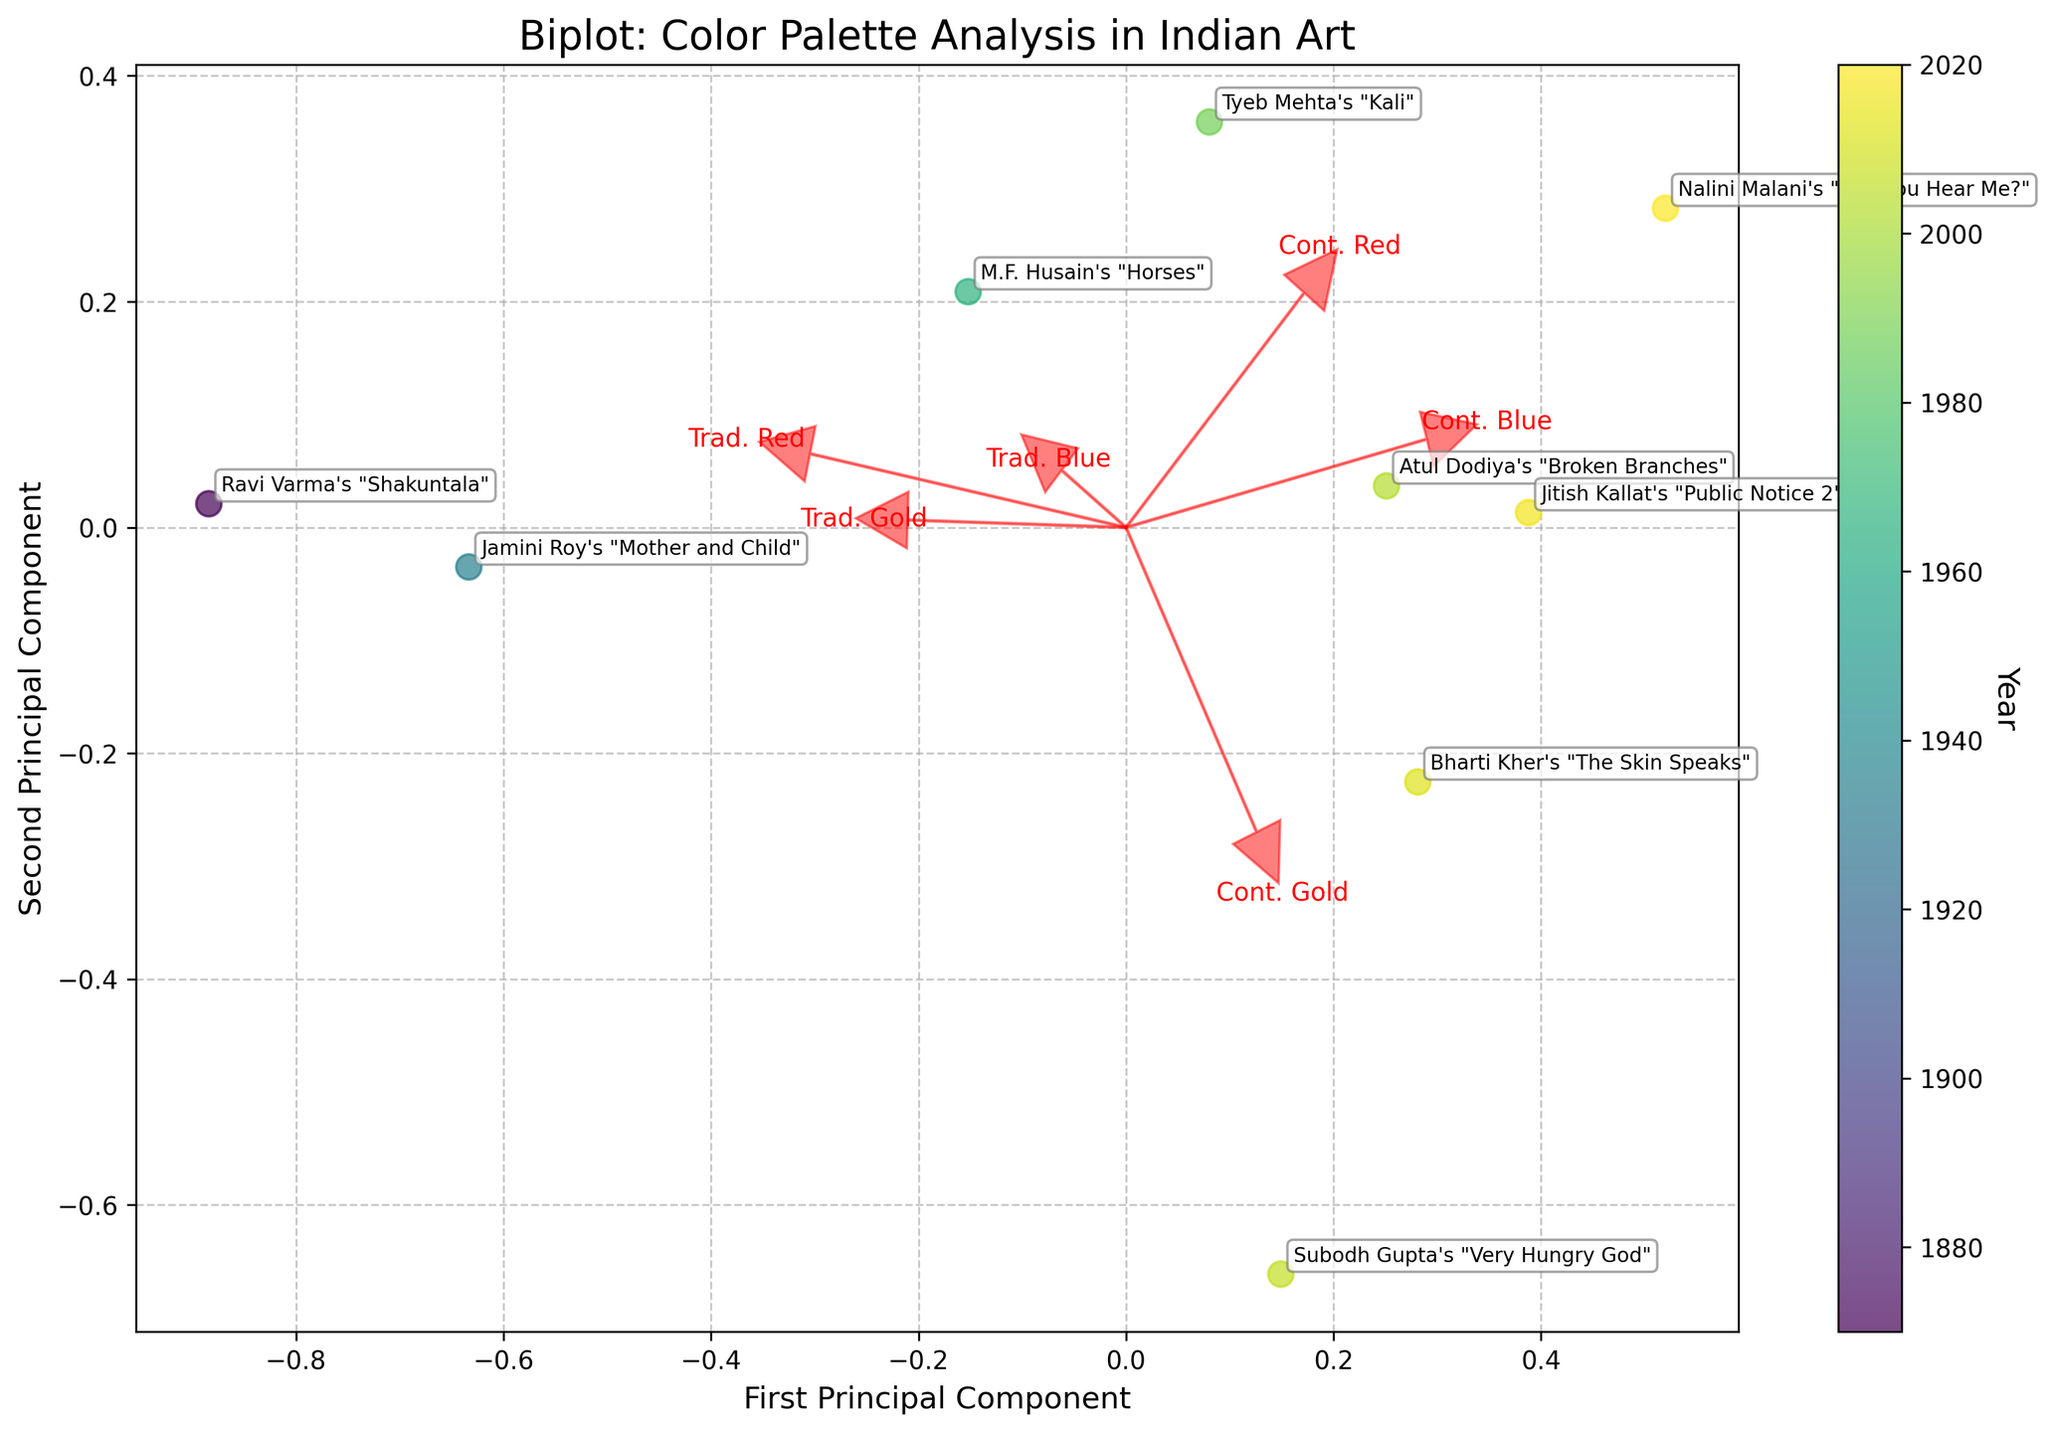What's the title of the plot? The title is found at the top of the figure where it summarizes the main subject or purpose of the plot. Here it is titled "Biplot: Color Palette Analysis in Indian Art".
Answer: Biplot: Color Palette Analysis in Indian Art What are the labels of the axes in the plot? The labels of the axes can be found on the horizontal (x-axis) and vertical (y-axis). For this plot, the horizontal axis is labeled "First Principal Component" and the vertical axis is labeled "Second Principal Component".
Answer: First Principal Component, Second Principal Component How are the years represented in the plot? The years of the artworks are indicated by the color of the data points in the scatter plot. The color gradient ranges from a certain start year to end year, represented by the color bar on the right side of the plot.
Answer: By the color of the data points Which artwork is projected closest to the First Principal Component axis? The artwork closest to the First Principal Component axis is the one with the smallest value on the Second Principal Component axis. In this figure, it's "Jitish Kallat's 'Public Notice 2'".
Answer: Jitish Kallat's "Public Notice 2" Among the artworks, which one used the highest proportion of Contemporary Gold? This can be identified by looking at the vector labeled "Cont. Gold" and checking the closest projection to that vector among the data points. "Subodh Gupta's 'Very Hungry God'" is closest to this vector.
Answer: Subodh Gupta's "Very Hungry God" What trend in the color palette usage can be inferred from the arrows for traditional and contemporary colors? By observing the direction and length of the arrows in the biplot, we see that traditional colors (Red, Blue, Gold) tend to cluster towards earlier years, while contemporary colors (Red, Blue, Gold) show a shift towards more recent years indicating a shift in the color palette over time.
Answer: Traditional colors cluster earlier, contemporary colors shift later Which two artworks have the greatest distance between them on the biplot, implying the most different color palettes? To find this, look for the two data points that are farthest apart from each other. "Ravi Varma's 'Shakuntala'" and "Nalini Malani's 'Can You Hear Me?'" appear to have the greatest distance between them.
Answer: Ravi Varma's "Shakuntala" and Nalini Malani's "Can You Hear Me?" What principal component has the larger influence in distinguishing the artworks? This can be inferred by comparing the spread of the data points along the First and Second Principal Component axes. There is generally a wider spread along the First Principal Component, indicating it has a larger influence.
Answer: First Principal Component 